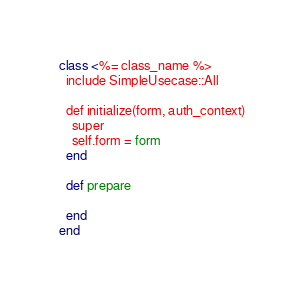<code> <loc_0><loc_0><loc_500><loc_500><_Ruby_>class <%= class_name %>
  include SimpleUsecase::All

  def initialize(form, auth_context)
    super
    self.form = form
  end

  def prepare

  end
end
</code> 